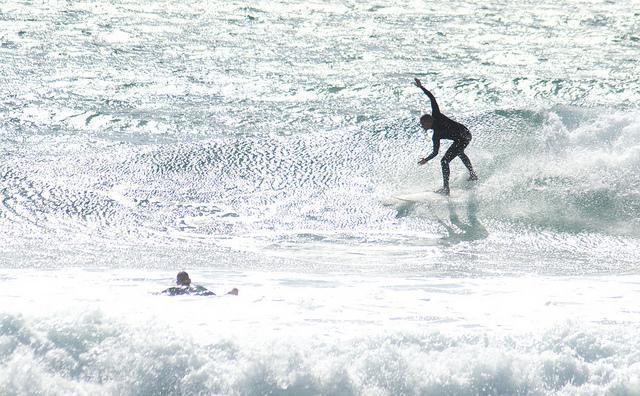Why is the man holding his arms out?
Choose the correct response, then elucidate: 'Answer: answer
Rationale: rationale.'
Options: To dance, to dive, to wave, to balance. Answer: to balance.
Rationale: He is trying to stay standing on a surf board that is moving in the waves. 